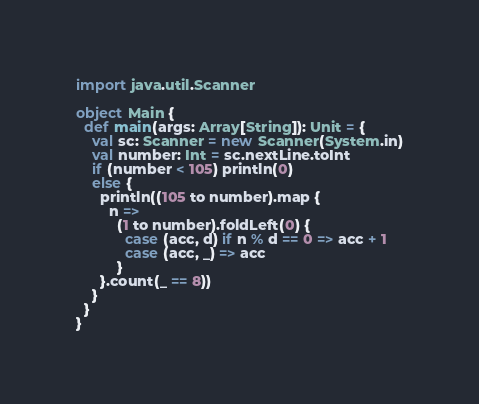Convert code to text. <code><loc_0><loc_0><loc_500><loc_500><_Scala_>import java.util.Scanner

object Main {
  def main(args: Array[String]): Unit = {
    val sc: Scanner = new Scanner(System.in)
    val number: Int = sc.nextLine.toInt
    if (number < 105) println(0)
    else {
      println((105 to number).map {
        n =>
          (1 to number).foldLeft(0) {
            case (acc, d) if n % d == 0 => acc + 1
            case (acc, _) => acc
          }
      }.count(_ == 8))
    }
  }
}
</code> 